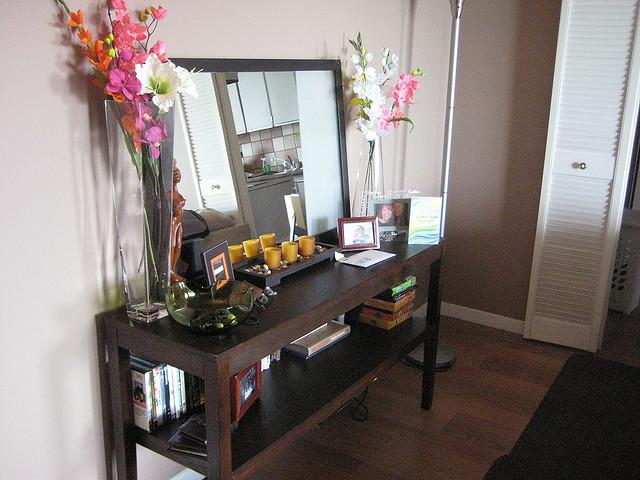What is behind the small table with the flowers?

Choices:
A) baby
B) glasses
C) mirror
D) cat mirror 